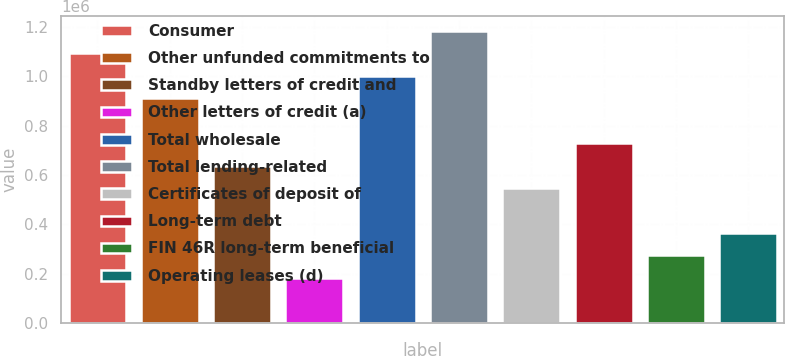Convert chart. <chart><loc_0><loc_0><loc_500><loc_500><bar_chart><fcel>Consumer<fcel>Other unfunded commitments to<fcel>Standby letters of credit and<fcel>Other letters of credit (a)<fcel>Total wholesale<fcel>Total lending-related<fcel>Certificates of deposit of<fcel>Long-term debt<fcel>FIN 46R long-term beneficial<fcel>Operating leases (d)<nl><fcel>1.09217e+06<fcel>910595<fcel>638239<fcel>184313<fcel>1.00138e+06<fcel>1.18295e+06<fcel>547454<fcel>729024<fcel>275098<fcel>365883<nl></chart> 